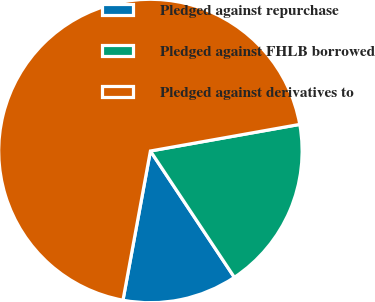<chart> <loc_0><loc_0><loc_500><loc_500><pie_chart><fcel>Pledged against repurchase<fcel>Pledged against FHLB borrowed<fcel>Pledged against derivatives to<nl><fcel>12.23%<fcel>18.47%<fcel>69.3%<nl></chart> 